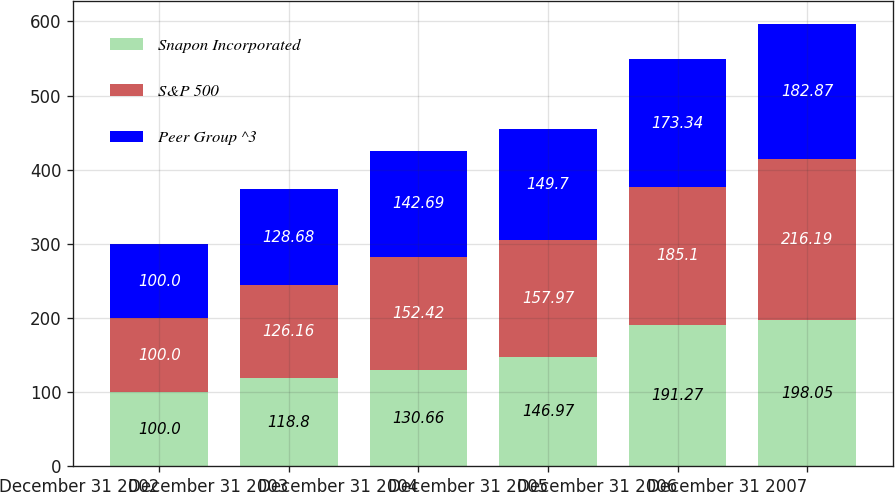Convert chart to OTSL. <chart><loc_0><loc_0><loc_500><loc_500><stacked_bar_chart><ecel><fcel>December 31 2002<fcel>December 31 2003<fcel>December 31 2004<fcel>December 31 2005<fcel>December 31 2006<fcel>December 31 2007<nl><fcel>Snapon Incorporated<fcel>100<fcel>118.8<fcel>130.66<fcel>146.97<fcel>191.27<fcel>198.05<nl><fcel>S&P 500<fcel>100<fcel>126.16<fcel>152.42<fcel>157.97<fcel>185.1<fcel>216.19<nl><fcel>Peer Group ^3<fcel>100<fcel>128.68<fcel>142.69<fcel>149.7<fcel>173.34<fcel>182.87<nl></chart> 